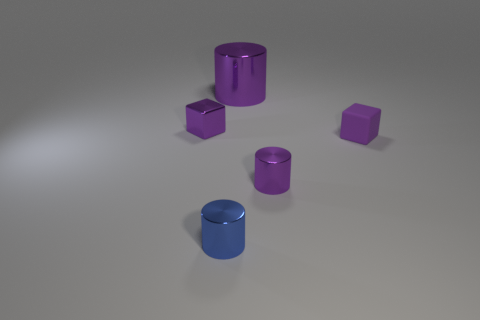Subtract all tiny metal cylinders. How many cylinders are left? 1 Add 4 big cyan rubber cylinders. How many objects exist? 9 Subtract all blue cylinders. How many cylinders are left? 2 Subtract all cubes. How many objects are left? 3 Subtract 1 cylinders. How many cylinders are left? 2 Subtract all cyan cylinders. Subtract all purple balls. How many cylinders are left? 3 Subtract all yellow cylinders. How many red blocks are left? 0 Subtract all small purple metal balls. Subtract all cylinders. How many objects are left? 2 Add 3 small cubes. How many small cubes are left? 5 Add 5 small purple matte objects. How many small purple matte objects exist? 6 